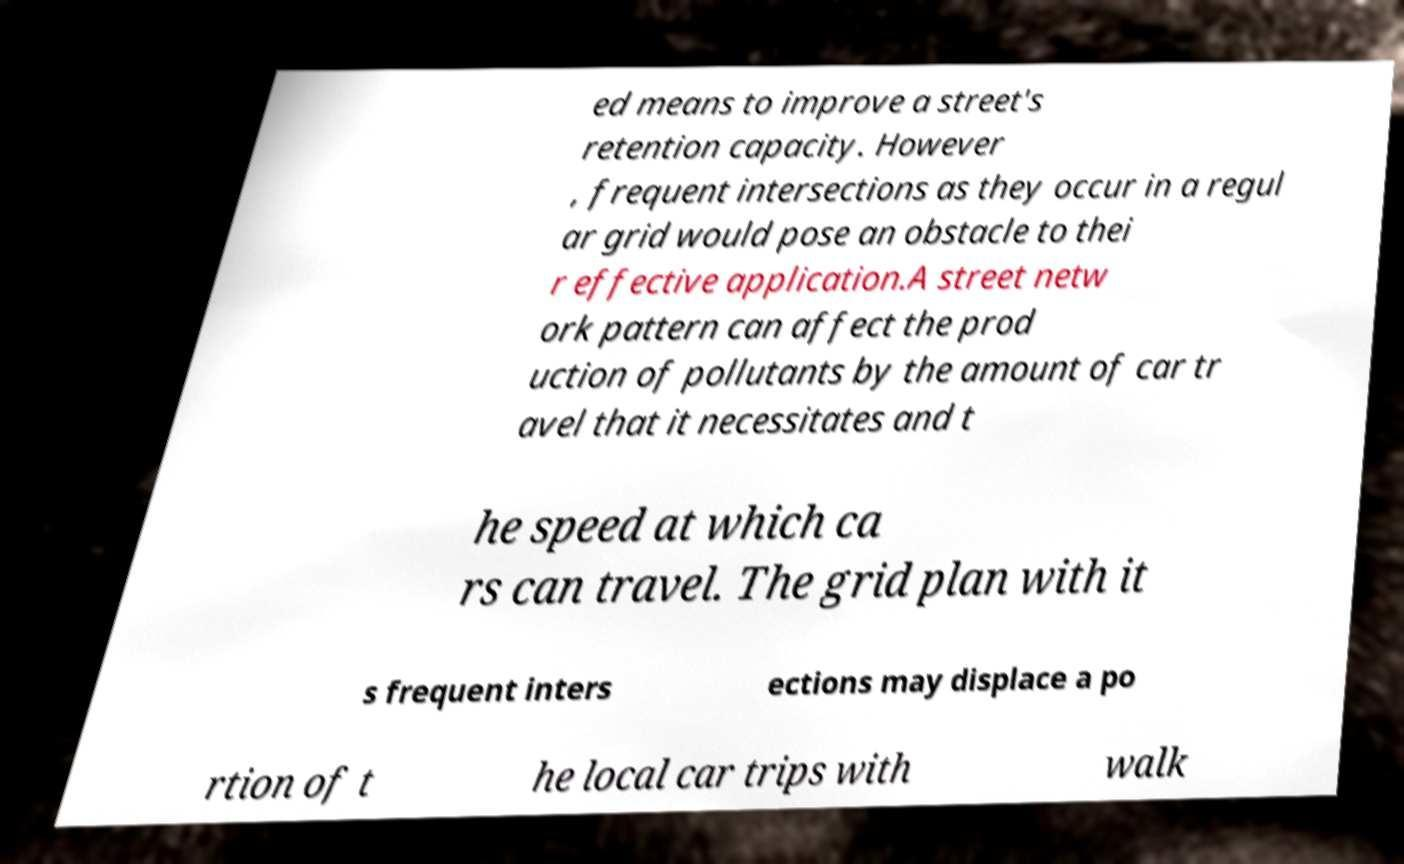Please read and relay the text visible in this image. What does it say? ed means to improve a street's retention capacity. However , frequent intersections as they occur in a regul ar grid would pose an obstacle to thei r effective application.A street netw ork pattern can affect the prod uction of pollutants by the amount of car tr avel that it necessitates and t he speed at which ca rs can travel. The grid plan with it s frequent inters ections may displace a po rtion of t he local car trips with walk 